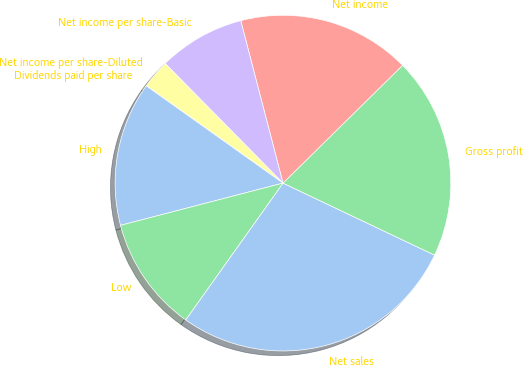Convert chart to OTSL. <chart><loc_0><loc_0><loc_500><loc_500><pie_chart><fcel>Net sales<fcel>Gross profit<fcel>Net income<fcel>Net income per share-Basic<fcel>Net income per share-Diluted<fcel>Dividends paid per share<fcel>High<fcel>Low<nl><fcel>27.78%<fcel>19.44%<fcel>16.67%<fcel>8.33%<fcel>2.78%<fcel>0.0%<fcel>13.89%<fcel>11.11%<nl></chart> 